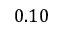<formula> <loc_0><loc_0><loc_500><loc_500>0 . 1 0</formula> 